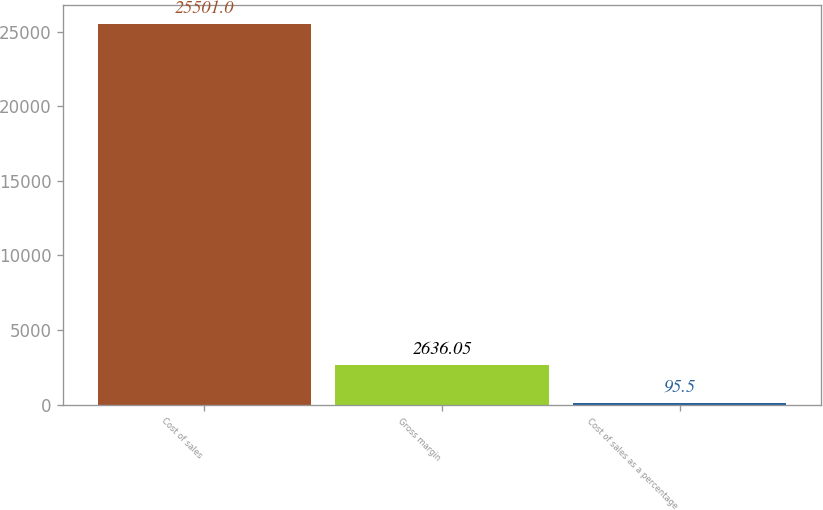Convert chart. <chart><loc_0><loc_0><loc_500><loc_500><bar_chart><fcel>Cost of sales<fcel>Gross margin<fcel>Cost of sales as a percentage<nl><fcel>25501<fcel>2636.05<fcel>95.5<nl></chart> 